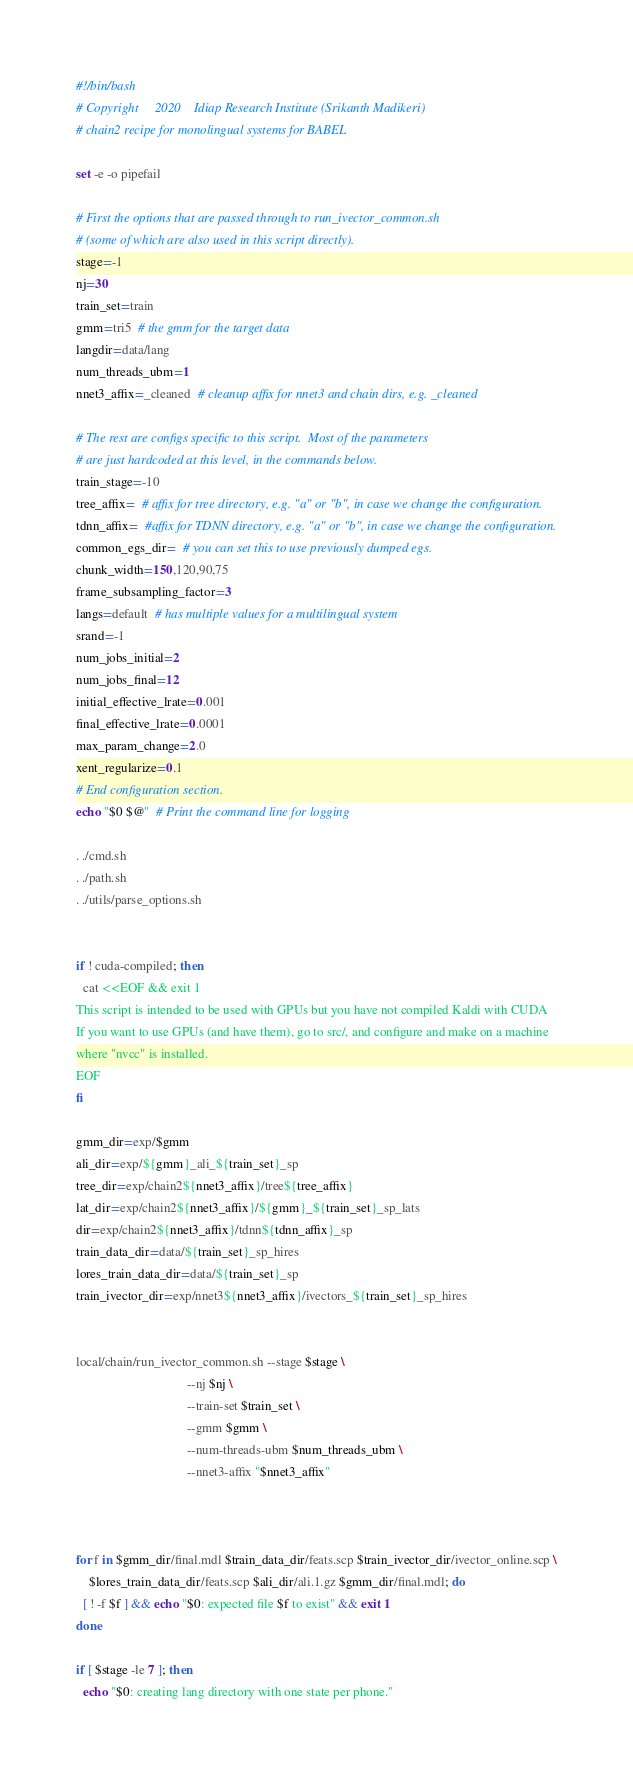<code> <loc_0><loc_0><loc_500><loc_500><_Bash_>#!/bin/bash
# Copyright     2020    Idiap Research Institute (Srikanth Madikeri)
# chain2 recipe for monolingual systems for BABEL

set -e -o pipefail

# First the options that are passed through to run_ivector_common.sh
# (some of which are also used in this script directly).
stage=-1
nj=30
train_set=train
gmm=tri5  # the gmm for the target data
langdir=data/lang
num_threads_ubm=1
nnet3_affix=_cleaned  # cleanup affix for nnet3 and chain dirs, e.g. _cleaned

# The rest are configs specific to this script.  Most of the parameters
# are just hardcoded at this level, in the commands below.
train_stage=-10
tree_affix=  # affix for tree directory, e.g. "a" or "b", in case we change the configuration.
tdnn_affix=  #affix for TDNN directory, e.g. "a" or "b", in case we change the configuration.
common_egs_dir=  # you can set this to use previously dumped egs.
chunk_width=150,120,90,75
frame_subsampling_factor=3
langs=default  # has multiple values for a multilingual system
srand=-1
num_jobs_initial=2
num_jobs_final=12
initial_effective_lrate=0.001
final_effective_lrate=0.0001
max_param_change=2.0
xent_regularize=0.1
# End configuration section.
echo "$0 $@"  # Print the command line for logging

. ./cmd.sh
. ./path.sh
. ./utils/parse_options.sh


if ! cuda-compiled; then
  cat <<EOF && exit 1
This script is intended to be used with GPUs but you have not compiled Kaldi with CUDA
If you want to use GPUs (and have them), go to src/, and configure and make on a machine
where "nvcc" is installed.
EOF
fi

gmm_dir=exp/$gmm
ali_dir=exp/${gmm}_ali_${train_set}_sp
tree_dir=exp/chain2${nnet3_affix}/tree${tree_affix}
lat_dir=exp/chain2${nnet3_affix}/${gmm}_${train_set}_sp_lats
dir=exp/chain2${nnet3_affix}/tdnn${tdnn_affix}_sp
train_data_dir=data/${train_set}_sp_hires
lores_train_data_dir=data/${train_set}_sp
train_ivector_dir=exp/nnet3${nnet3_affix}/ivectors_${train_set}_sp_hires


local/chain/run_ivector_common.sh --stage $stage \
                                  --nj $nj \
                                  --train-set $train_set \
                                  --gmm $gmm \
                                  --num-threads-ubm $num_threads_ubm \
                                  --nnet3-affix "$nnet3_affix"



for f in $gmm_dir/final.mdl $train_data_dir/feats.scp $train_ivector_dir/ivector_online.scp \
    $lores_train_data_dir/feats.scp $ali_dir/ali.1.gz $gmm_dir/final.mdl; do
  [ ! -f $f ] && echo "$0: expected file $f to exist" && exit 1
done

if [ $stage -le 7 ]; then
  echo "$0: creating lang directory with one state per phone."</code> 